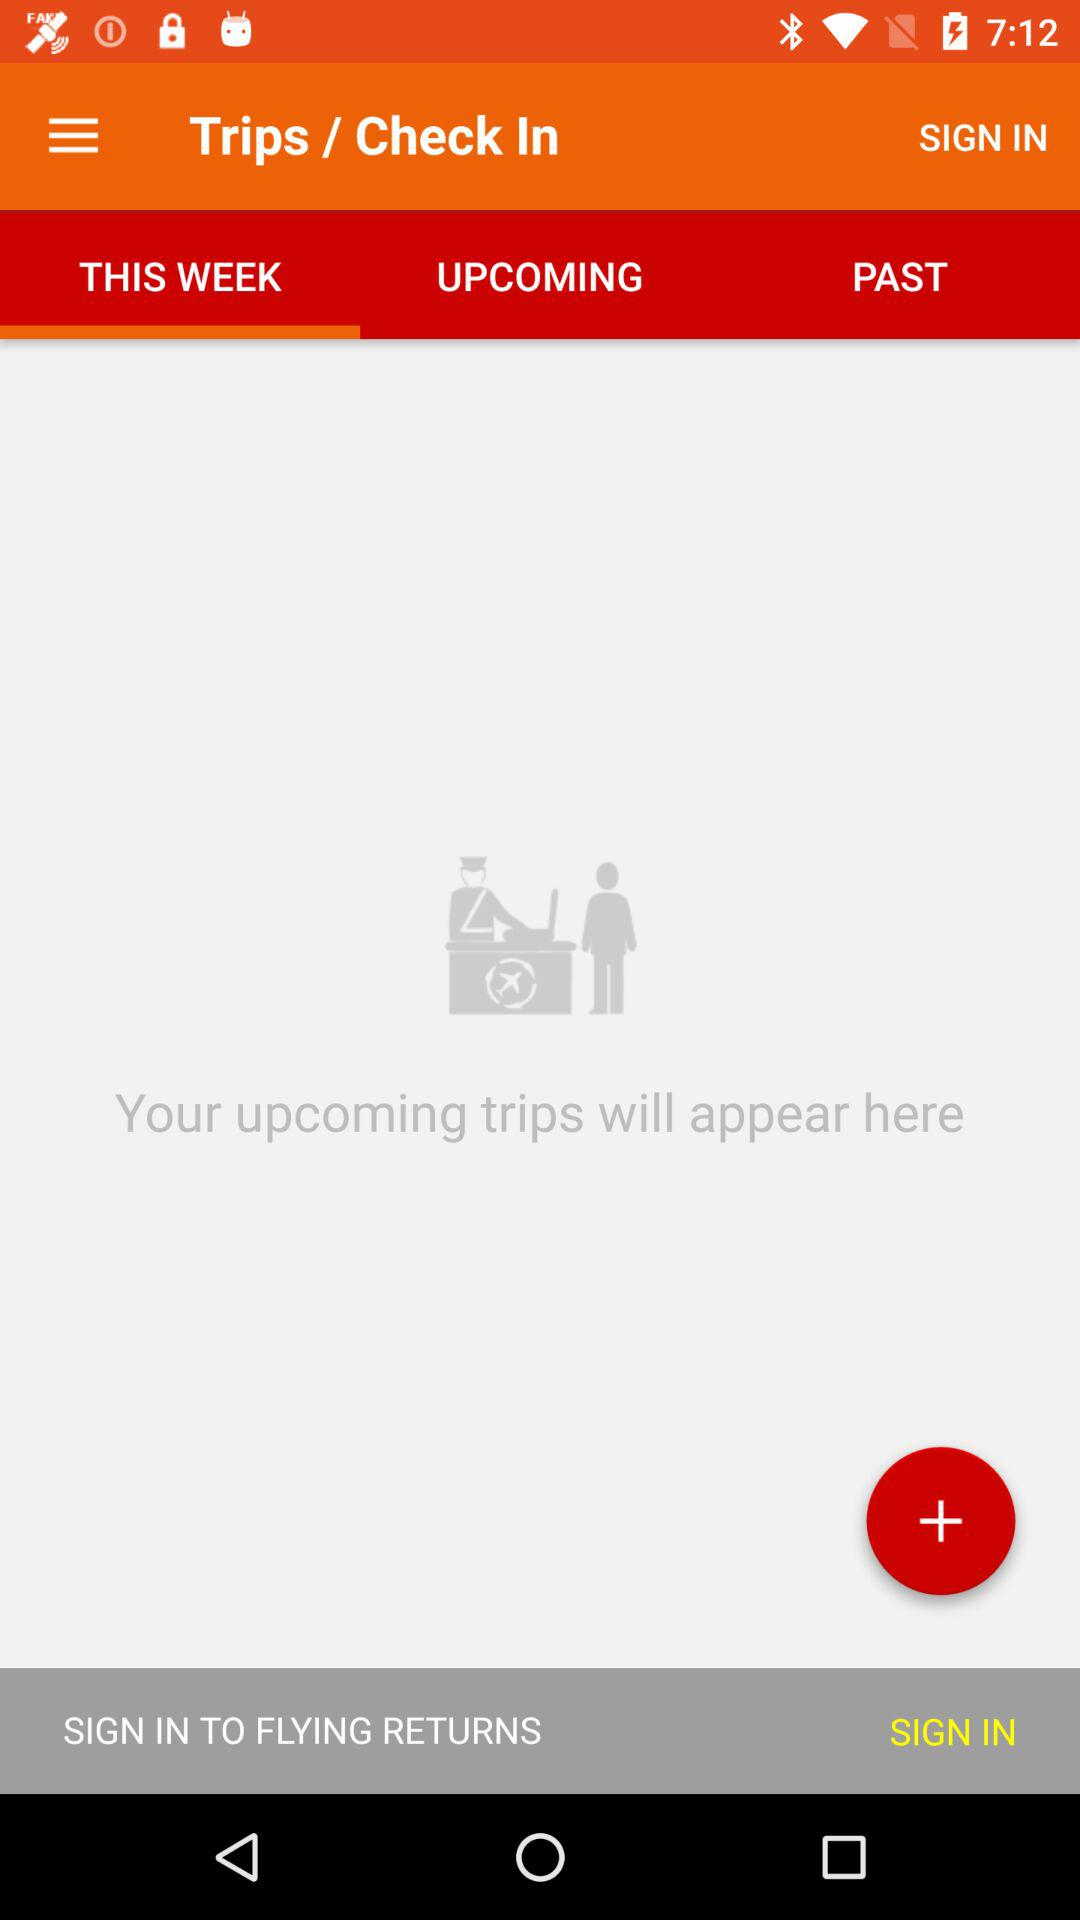Which tab is open? The tab is "This Week". 